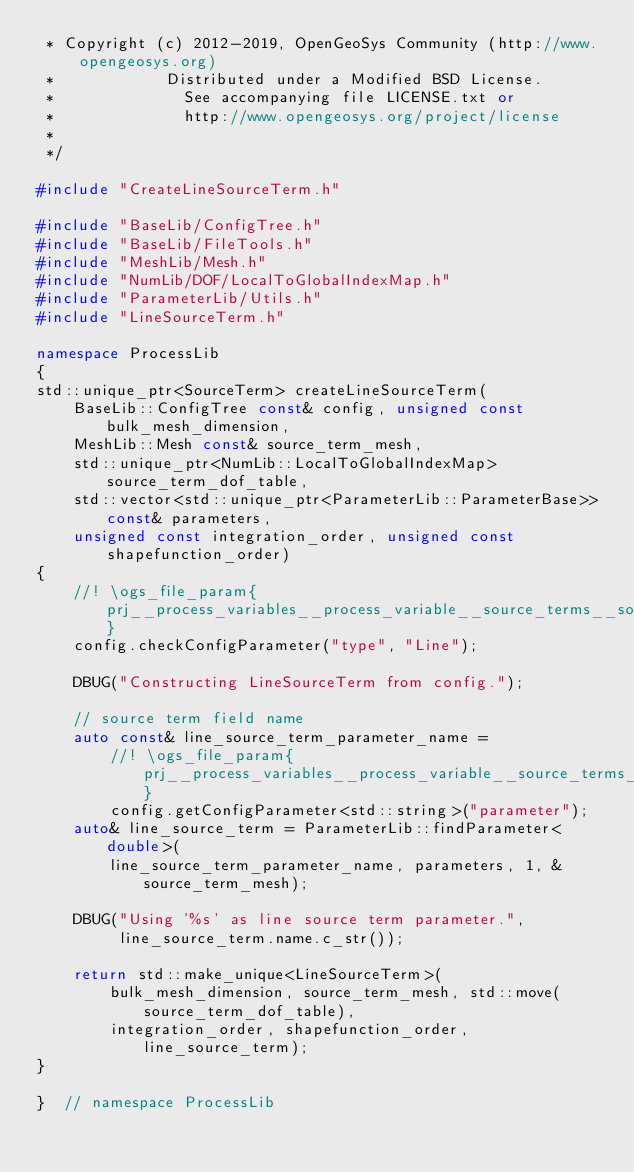<code> <loc_0><loc_0><loc_500><loc_500><_C++_> * Copyright (c) 2012-2019, OpenGeoSys Community (http://www.opengeosys.org)
 *            Distributed under a Modified BSD License.
 *              See accompanying file LICENSE.txt or
 *              http://www.opengeosys.org/project/license
 *
 */

#include "CreateLineSourceTerm.h"

#include "BaseLib/ConfigTree.h"
#include "BaseLib/FileTools.h"
#include "MeshLib/Mesh.h"
#include "NumLib/DOF/LocalToGlobalIndexMap.h"
#include "ParameterLib/Utils.h"
#include "LineSourceTerm.h"

namespace ProcessLib
{
std::unique_ptr<SourceTerm> createLineSourceTerm(
    BaseLib::ConfigTree const& config, unsigned const bulk_mesh_dimension,
    MeshLib::Mesh const& source_term_mesh,
    std::unique_ptr<NumLib::LocalToGlobalIndexMap> source_term_dof_table,
    std::vector<std::unique_ptr<ParameterLib::ParameterBase>> const& parameters,
    unsigned const integration_order, unsigned const shapefunction_order)
{
    //! \ogs_file_param{prj__process_variables__process_variable__source_terms__source_term__type}
    config.checkConfigParameter("type", "Line");

    DBUG("Constructing LineSourceTerm from config.");

    // source term field name
    auto const& line_source_term_parameter_name =
        //! \ogs_file_param{prj__process_variables__process_variable__source_terms__source_term__Line__parameter}
        config.getConfigParameter<std::string>("parameter");
    auto& line_source_term = ParameterLib::findParameter<double>(
        line_source_term_parameter_name, parameters, 1, &source_term_mesh);

    DBUG("Using '%s' as line source term parameter.",
         line_source_term.name.c_str());

    return std::make_unique<LineSourceTerm>(
        bulk_mesh_dimension, source_term_mesh, std::move(source_term_dof_table),
        integration_order, shapefunction_order, line_source_term);
}

}  // namespace ProcessLib
</code> 